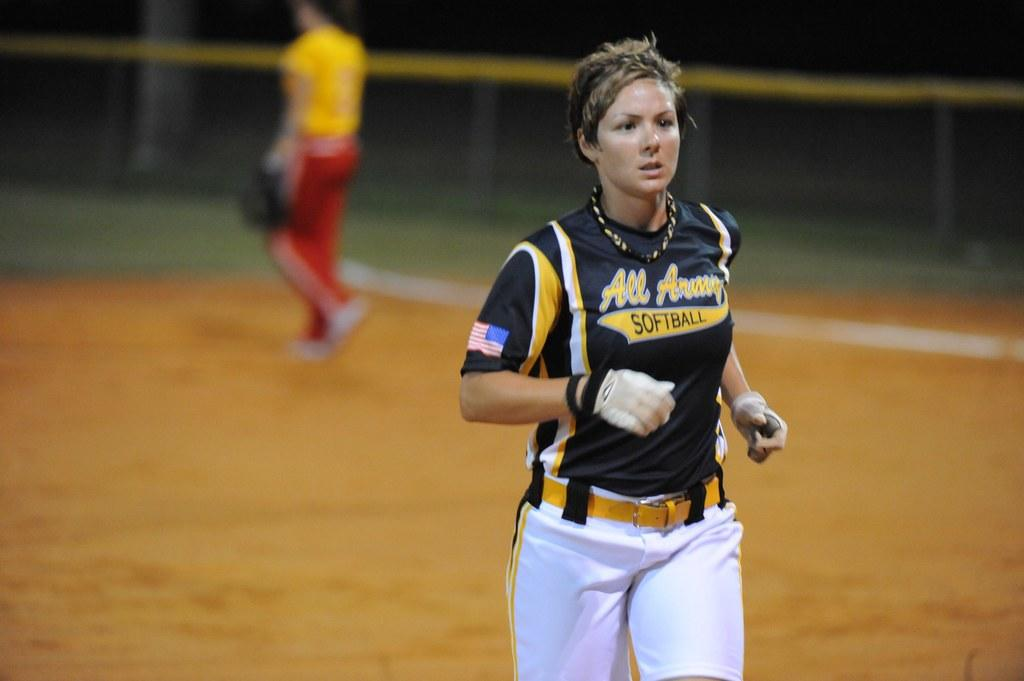<image>
Share a concise interpretation of the image provided. Female baseball player running on the field playing for team All Army Softball. 